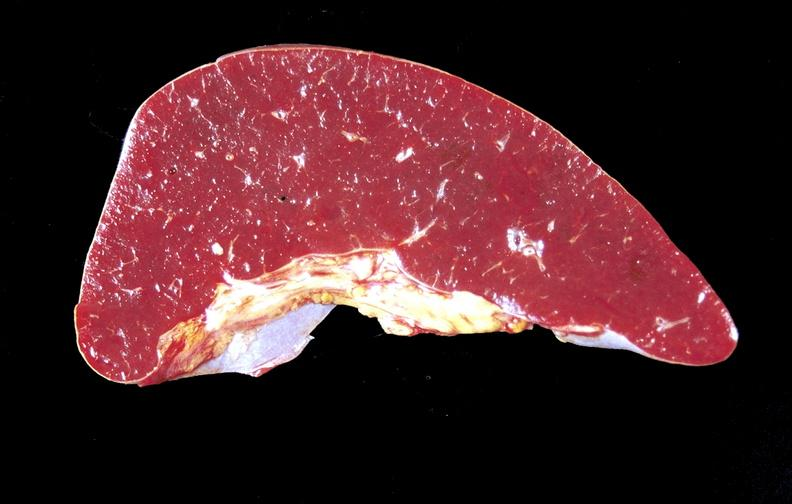does papillary intraductal adenocarcinoma show amyloid, spleen?
Answer the question using a single word or phrase. No 